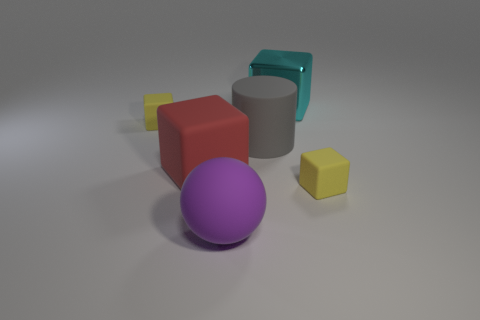Is there anything else that is the same material as the cyan block?
Make the answer very short. No. Are there any other yellow matte balls of the same size as the sphere?
Your answer should be very brief. No. There is a purple object that is the same size as the red matte object; what is it made of?
Provide a short and direct response. Rubber. Is there another gray rubber object of the same shape as the gray object?
Provide a short and direct response. No. The small yellow matte thing right of the shiny object has what shape?
Give a very brief answer. Cube. What number of large red matte cubes are there?
Your answer should be very brief. 1. There is a cylinder that is made of the same material as the large purple thing; what is its color?
Your answer should be very brief. Gray. What number of big things are purple cubes or purple spheres?
Your answer should be compact. 1. There is a large metallic cube; how many big cylinders are to the left of it?
Give a very brief answer. 1. What color is the large metal object that is the same shape as the red rubber thing?
Your answer should be very brief. Cyan. 